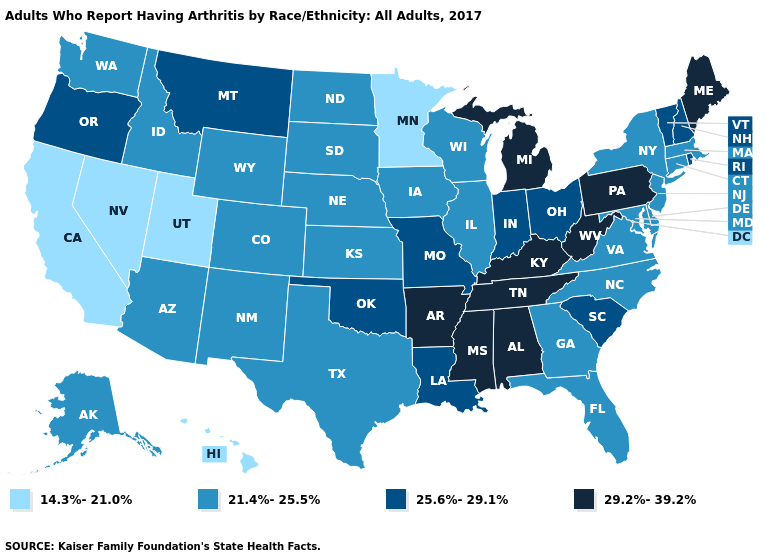Which states have the lowest value in the USA?
Answer briefly. California, Hawaii, Minnesota, Nevada, Utah. Does the first symbol in the legend represent the smallest category?
Quick response, please. Yes. Name the states that have a value in the range 14.3%-21.0%?
Answer briefly. California, Hawaii, Minnesota, Nevada, Utah. How many symbols are there in the legend?
Give a very brief answer. 4. Is the legend a continuous bar?
Give a very brief answer. No. Among the states that border Virginia , does Maryland have the highest value?
Answer briefly. No. Does Rhode Island have a lower value than Mississippi?
Be succinct. Yes. What is the value of Colorado?
Give a very brief answer. 21.4%-25.5%. Name the states that have a value in the range 29.2%-39.2%?
Answer briefly. Alabama, Arkansas, Kentucky, Maine, Michigan, Mississippi, Pennsylvania, Tennessee, West Virginia. Which states hav the highest value in the MidWest?
Short answer required. Michigan. Does Delaware have the same value as Mississippi?
Keep it brief. No. What is the highest value in states that border Illinois?
Short answer required. 29.2%-39.2%. Which states have the lowest value in the South?
Quick response, please. Delaware, Florida, Georgia, Maryland, North Carolina, Texas, Virginia. Name the states that have a value in the range 29.2%-39.2%?
Quick response, please. Alabama, Arkansas, Kentucky, Maine, Michigan, Mississippi, Pennsylvania, Tennessee, West Virginia. What is the value of California?
Quick response, please. 14.3%-21.0%. 